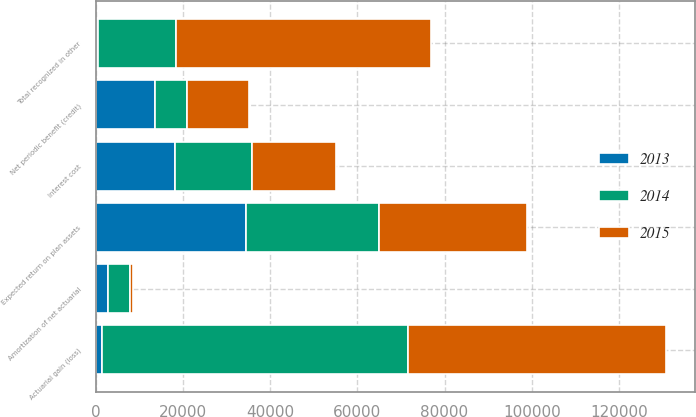Convert chart. <chart><loc_0><loc_0><loc_500><loc_500><stacked_bar_chart><ecel><fcel>Interest cost<fcel>Expected return on plan assets<fcel>Amortization of net actuarial<fcel>Net periodic benefit (credit)<fcel>Actuarial gain (loss)<fcel>Total recognized in other<nl><fcel>2013<fcel>18102<fcel>34432<fcel>2828<fcel>13502<fcel>1508<fcel>505<nl><fcel>2015<fcel>19073<fcel>33942<fcel>763<fcel>14106<fcel>59272<fcel>58509<nl><fcel>2014<fcel>17860<fcel>30480<fcel>5078<fcel>7542<fcel>70065<fcel>17860<nl></chart> 